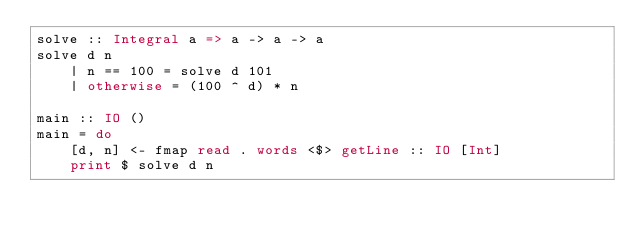Convert code to text. <code><loc_0><loc_0><loc_500><loc_500><_Haskell_>solve :: Integral a => a -> a -> a
solve d n
    | n == 100 = solve d 101
    | otherwise = (100 ^ d) * n

main :: IO ()
main = do
    [d, n] <- fmap read . words <$> getLine :: IO [Int]
    print $ solve d n
</code> 